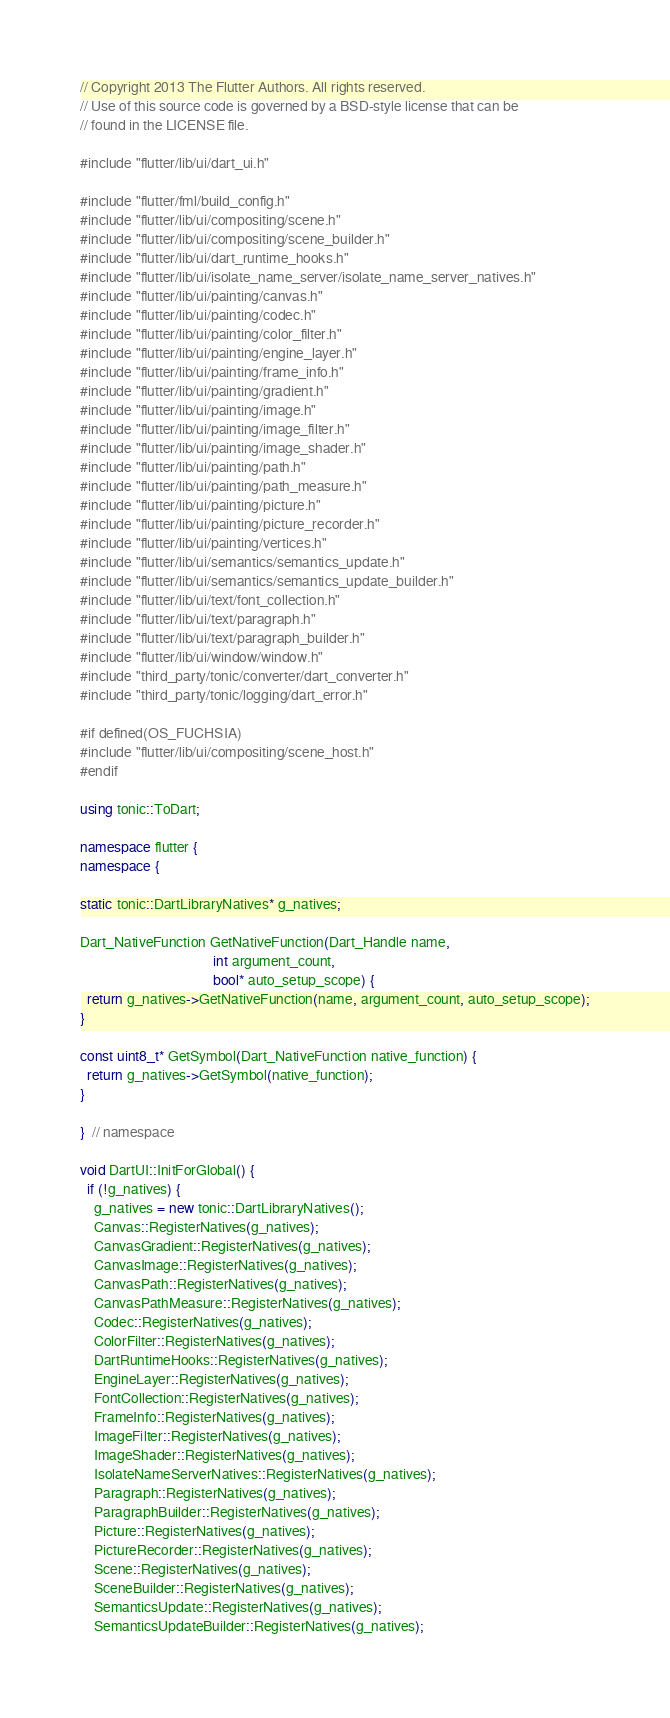<code> <loc_0><loc_0><loc_500><loc_500><_C++_>// Copyright 2013 The Flutter Authors. All rights reserved.
// Use of this source code is governed by a BSD-style license that can be
// found in the LICENSE file.

#include "flutter/lib/ui/dart_ui.h"

#include "flutter/fml/build_config.h"
#include "flutter/lib/ui/compositing/scene.h"
#include "flutter/lib/ui/compositing/scene_builder.h"
#include "flutter/lib/ui/dart_runtime_hooks.h"
#include "flutter/lib/ui/isolate_name_server/isolate_name_server_natives.h"
#include "flutter/lib/ui/painting/canvas.h"
#include "flutter/lib/ui/painting/codec.h"
#include "flutter/lib/ui/painting/color_filter.h"
#include "flutter/lib/ui/painting/engine_layer.h"
#include "flutter/lib/ui/painting/frame_info.h"
#include "flutter/lib/ui/painting/gradient.h"
#include "flutter/lib/ui/painting/image.h"
#include "flutter/lib/ui/painting/image_filter.h"
#include "flutter/lib/ui/painting/image_shader.h"
#include "flutter/lib/ui/painting/path.h"
#include "flutter/lib/ui/painting/path_measure.h"
#include "flutter/lib/ui/painting/picture.h"
#include "flutter/lib/ui/painting/picture_recorder.h"
#include "flutter/lib/ui/painting/vertices.h"
#include "flutter/lib/ui/semantics/semantics_update.h"
#include "flutter/lib/ui/semantics/semantics_update_builder.h"
#include "flutter/lib/ui/text/font_collection.h"
#include "flutter/lib/ui/text/paragraph.h"
#include "flutter/lib/ui/text/paragraph_builder.h"
#include "flutter/lib/ui/window/window.h"
#include "third_party/tonic/converter/dart_converter.h"
#include "third_party/tonic/logging/dart_error.h"

#if defined(OS_FUCHSIA)
#include "flutter/lib/ui/compositing/scene_host.h"
#endif

using tonic::ToDart;

namespace flutter {
namespace {

static tonic::DartLibraryNatives* g_natives;

Dart_NativeFunction GetNativeFunction(Dart_Handle name,
                                      int argument_count,
                                      bool* auto_setup_scope) {
  return g_natives->GetNativeFunction(name, argument_count, auto_setup_scope);
}

const uint8_t* GetSymbol(Dart_NativeFunction native_function) {
  return g_natives->GetSymbol(native_function);
}

}  // namespace

void DartUI::InitForGlobal() {
  if (!g_natives) {
    g_natives = new tonic::DartLibraryNatives();
    Canvas::RegisterNatives(g_natives);
    CanvasGradient::RegisterNatives(g_natives);
    CanvasImage::RegisterNatives(g_natives);
    CanvasPath::RegisterNatives(g_natives);
    CanvasPathMeasure::RegisterNatives(g_natives);
    Codec::RegisterNatives(g_natives);
    ColorFilter::RegisterNatives(g_natives);
    DartRuntimeHooks::RegisterNatives(g_natives);
    EngineLayer::RegisterNatives(g_natives);
    FontCollection::RegisterNatives(g_natives);
    FrameInfo::RegisterNatives(g_natives);
    ImageFilter::RegisterNatives(g_natives);
    ImageShader::RegisterNatives(g_natives);
    IsolateNameServerNatives::RegisterNatives(g_natives);
    Paragraph::RegisterNatives(g_natives);
    ParagraphBuilder::RegisterNatives(g_natives);
    Picture::RegisterNatives(g_natives);
    PictureRecorder::RegisterNatives(g_natives);
    Scene::RegisterNatives(g_natives);
    SceneBuilder::RegisterNatives(g_natives);
    SemanticsUpdate::RegisterNatives(g_natives);
    SemanticsUpdateBuilder::RegisterNatives(g_natives);</code> 